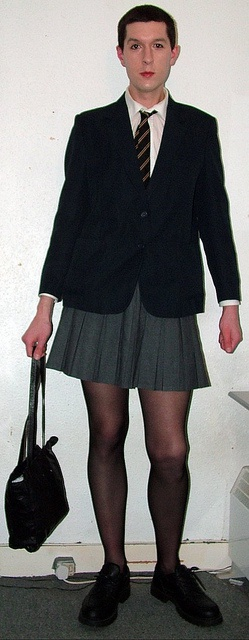Describe the objects in this image and their specific colors. I can see people in lightgray, black, salmon, maroon, and brown tones, handbag in lightgray, black, gray, and darkgray tones, and tie in lightgray, black, gray, and maroon tones in this image. 